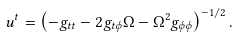<formula> <loc_0><loc_0><loc_500><loc_500>u ^ { t } = \left ( - g _ { t t } - 2 g _ { t \phi } \Omega - \Omega ^ { 2 } g _ { \phi \phi } \right ) ^ { - 1 / 2 } .</formula> 